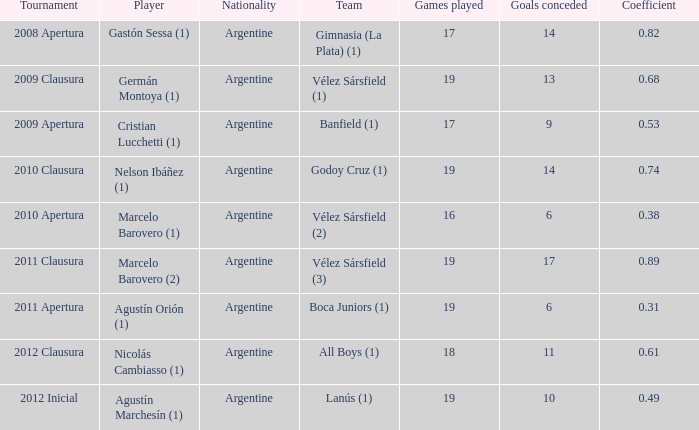Which team was in the 2012 clausura tournament? All Boys (1). 